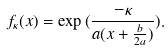<formula> <loc_0><loc_0><loc_500><loc_500>f _ { \kappa } ( x ) = \exp { ( \frac { - \kappa } { a ( x + \frac { b } { 2 a } ) } ) } .</formula> 